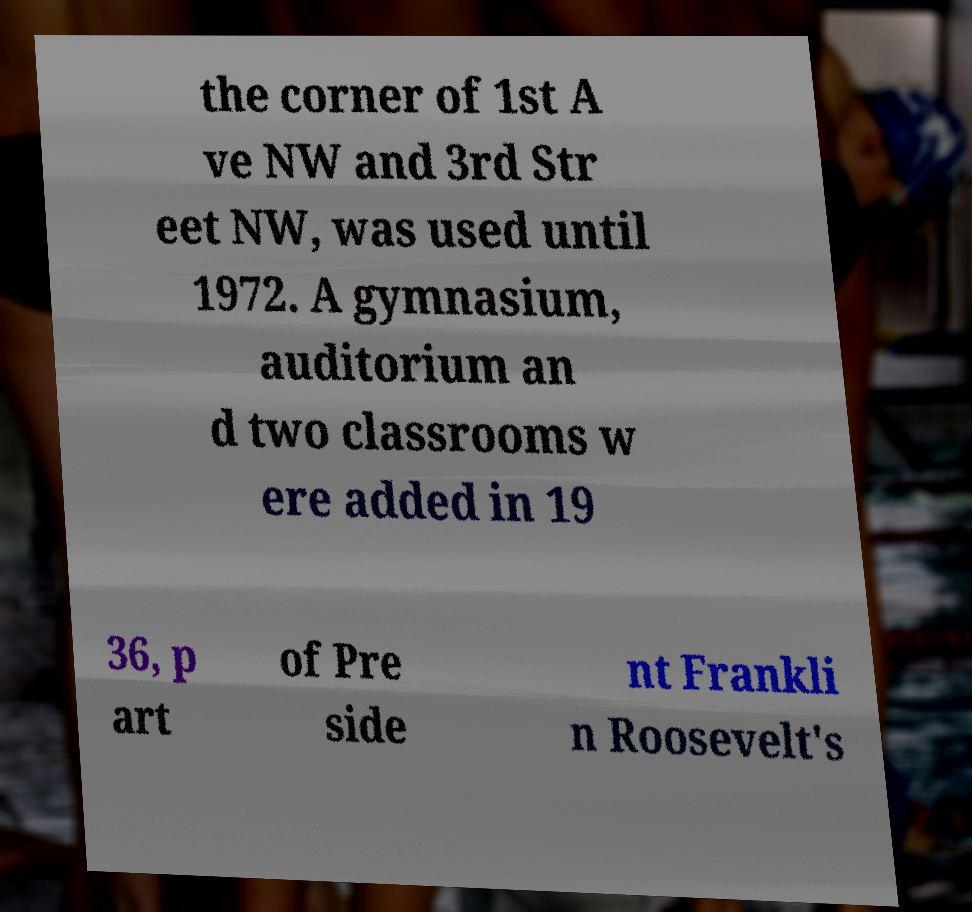I need the written content from this picture converted into text. Can you do that? the corner of 1st A ve NW and 3rd Str eet NW, was used until 1972. A gymnasium, auditorium an d two classrooms w ere added in 19 36, p art of Pre side nt Frankli n Roosevelt's 